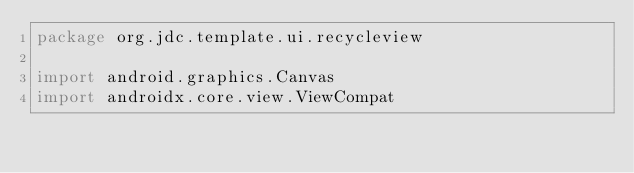Convert code to text. <code><loc_0><loc_0><loc_500><loc_500><_Kotlin_>package org.jdc.template.ui.recycleview

import android.graphics.Canvas
import androidx.core.view.ViewCompat</code> 